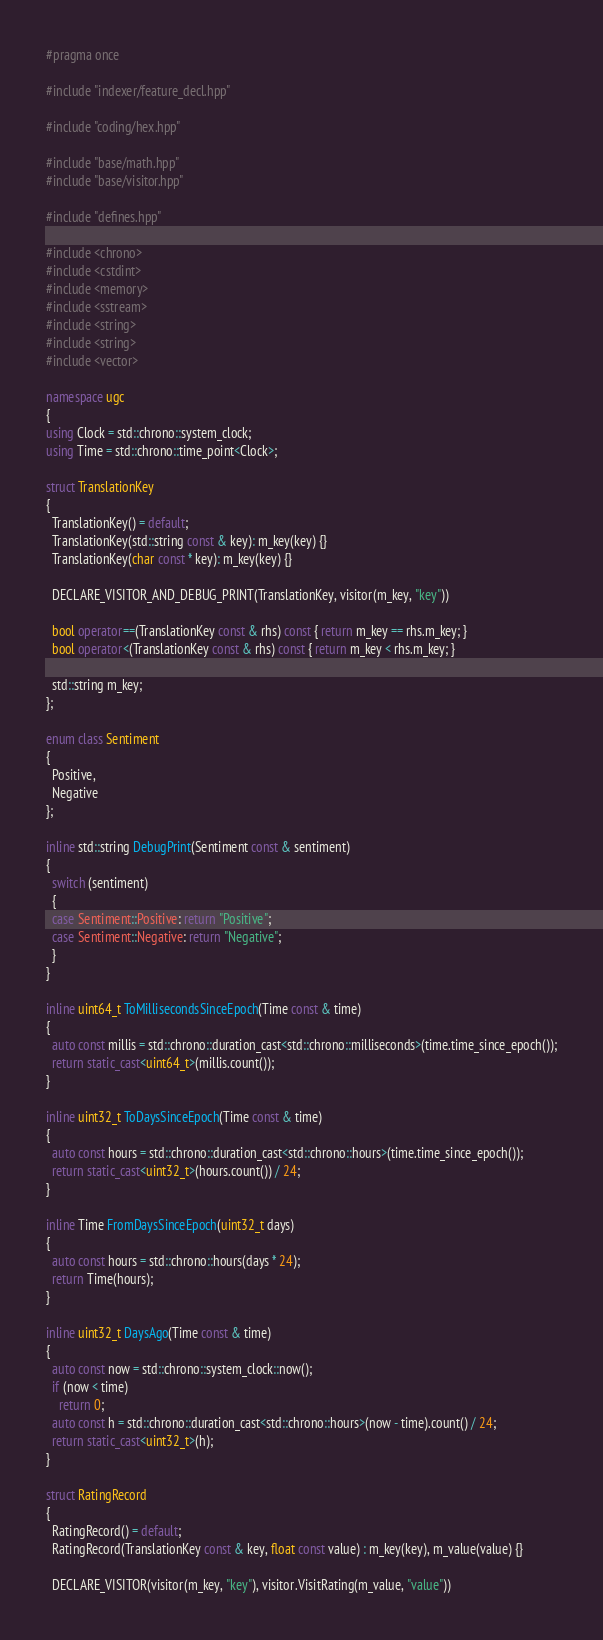<code> <loc_0><loc_0><loc_500><loc_500><_C++_>#pragma once

#include "indexer/feature_decl.hpp"

#include "coding/hex.hpp"

#include "base/math.hpp"
#include "base/visitor.hpp"

#include "defines.hpp"

#include <chrono>
#include <cstdint>
#include <memory>
#include <sstream>
#include <string>
#include <string>
#include <vector>

namespace ugc
{
using Clock = std::chrono::system_clock;
using Time = std::chrono::time_point<Clock>;

struct TranslationKey
{
  TranslationKey() = default;
  TranslationKey(std::string const & key): m_key(key) {}
  TranslationKey(char const * key): m_key(key) {}

  DECLARE_VISITOR_AND_DEBUG_PRINT(TranslationKey, visitor(m_key, "key"))

  bool operator==(TranslationKey const & rhs) const { return m_key == rhs.m_key; }
  bool operator<(TranslationKey const & rhs) const { return m_key < rhs.m_key; }

  std::string m_key;
};

enum class Sentiment
{
  Positive,
  Negative
};

inline std::string DebugPrint(Sentiment const & sentiment)
{
  switch (sentiment)
  {
  case Sentiment::Positive: return "Positive";
  case Sentiment::Negative: return "Negative";
  }
}

inline uint64_t ToMillisecondsSinceEpoch(Time const & time)
{
  auto const millis = std::chrono::duration_cast<std::chrono::milliseconds>(time.time_since_epoch());
  return static_cast<uint64_t>(millis.count());
}

inline uint32_t ToDaysSinceEpoch(Time const & time)
{
  auto const hours = std::chrono::duration_cast<std::chrono::hours>(time.time_since_epoch());
  return static_cast<uint32_t>(hours.count()) / 24;
}

inline Time FromDaysSinceEpoch(uint32_t days)
{
  auto const hours = std::chrono::hours(days * 24);
  return Time(hours);
}

inline uint32_t DaysAgo(Time const & time)
{
  auto const now = std::chrono::system_clock::now();
  if (now < time)
    return 0;
  auto const h = std::chrono::duration_cast<std::chrono::hours>(now - time).count() / 24;
  return static_cast<uint32_t>(h);
}

struct RatingRecord
{
  RatingRecord() = default;
  RatingRecord(TranslationKey const & key, float const value) : m_key(key), m_value(value) {}

  DECLARE_VISITOR(visitor(m_key, "key"), visitor.VisitRating(m_value, "value"))
</code> 